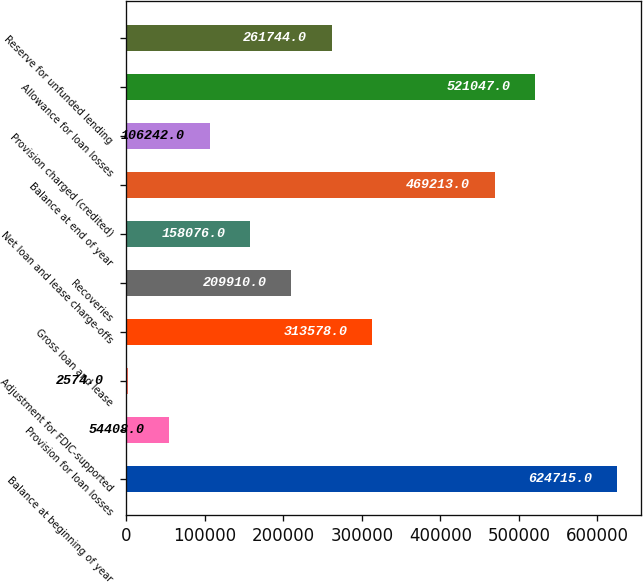Convert chart to OTSL. <chart><loc_0><loc_0><loc_500><loc_500><bar_chart><fcel>Balance at beginning of year<fcel>Provision for loan losses<fcel>Adjustment for FDIC-supported<fcel>Gross loan and lease<fcel>Recoveries<fcel>Net loan and lease charge-offs<fcel>Balance at end of year<fcel>Provision charged (credited)<fcel>Allowance for loan losses<fcel>Reserve for unfunded lending<nl><fcel>624715<fcel>54408<fcel>2574<fcel>313578<fcel>209910<fcel>158076<fcel>469213<fcel>106242<fcel>521047<fcel>261744<nl></chart> 